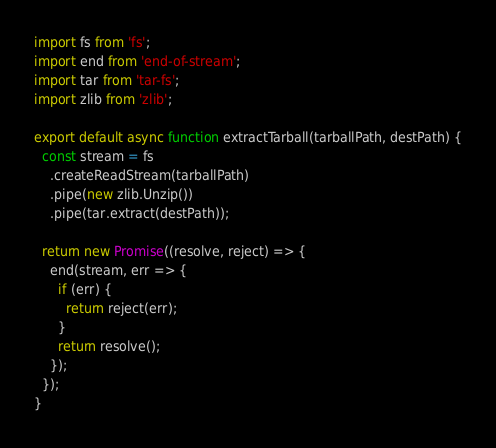Convert code to text. <code><loc_0><loc_0><loc_500><loc_500><_JavaScript_>import fs from 'fs';
import end from 'end-of-stream';
import tar from 'tar-fs';
import zlib from 'zlib';

export default async function extractTarball(tarballPath, destPath) {
  const stream = fs
    .createReadStream(tarballPath)
    .pipe(new zlib.Unzip())
    .pipe(tar.extract(destPath));

  return new Promise((resolve, reject) => {
    end(stream, err => {
      if (err) {
        return reject(err);
      }
      return resolve();
    });
  });
}
</code> 